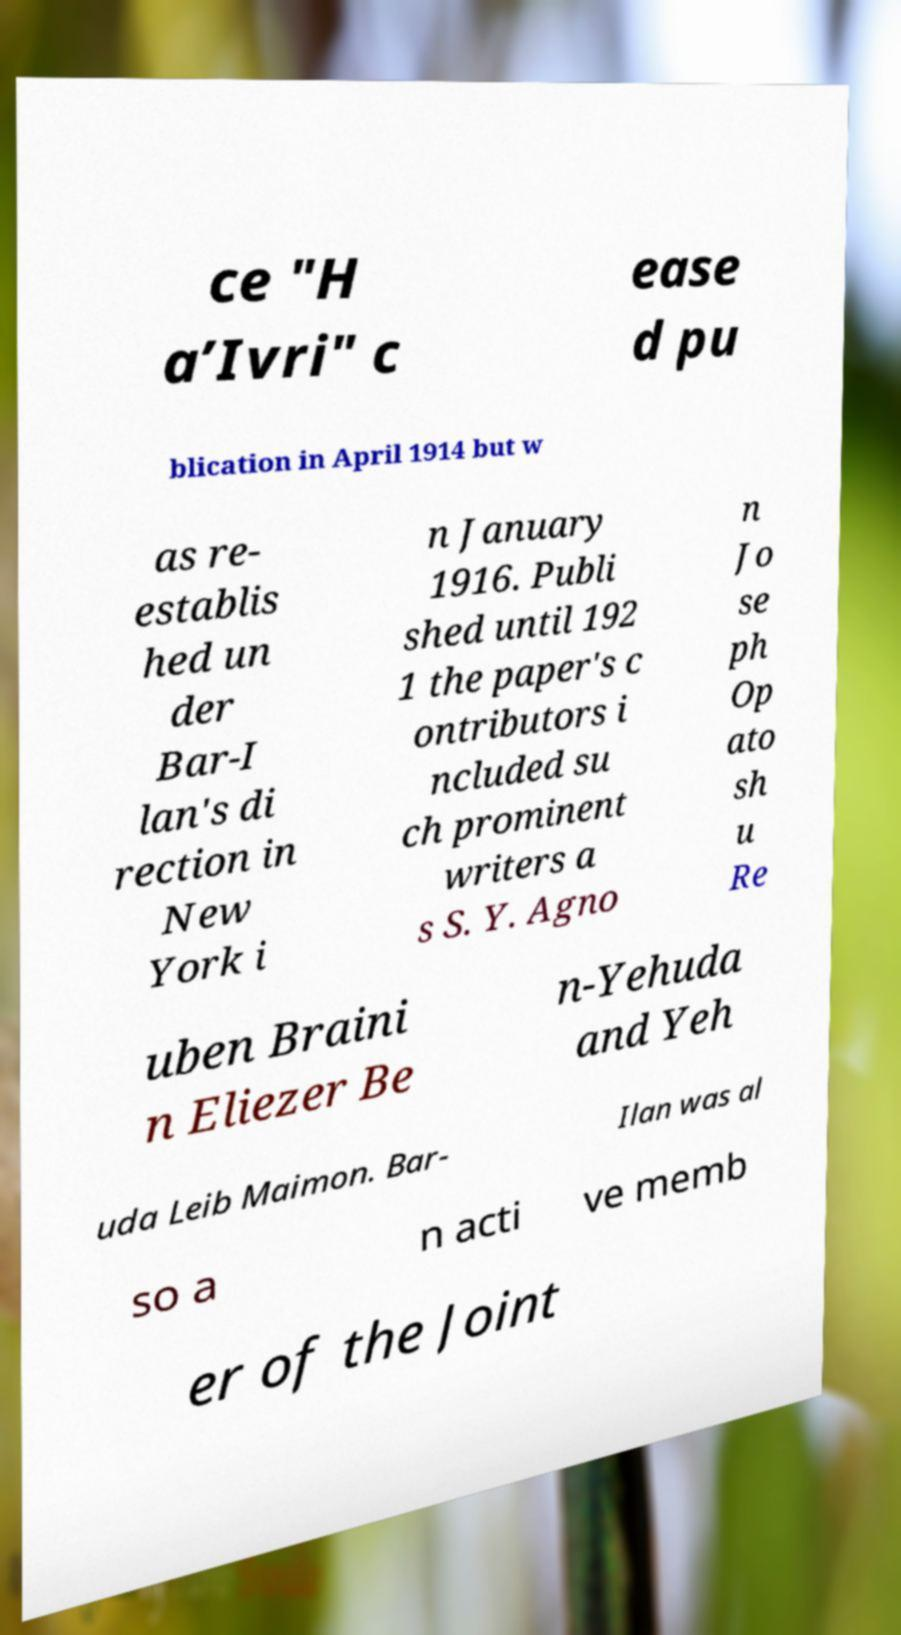Can you accurately transcribe the text from the provided image for me? ce "H a’Ivri" c ease d pu blication in April 1914 but w as re- establis hed un der Bar-I lan's di rection in New York i n January 1916. Publi shed until 192 1 the paper's c ontributors i ncluded su ch prominent writers a s S. Y. Agno n Jo se ph Op ato sh u Re uben Braini n Eliezer Be n-Yehuda and Yeh uda Leib Maimon. Bar- Ilan was al so a n acti ve memb er of the Joint 